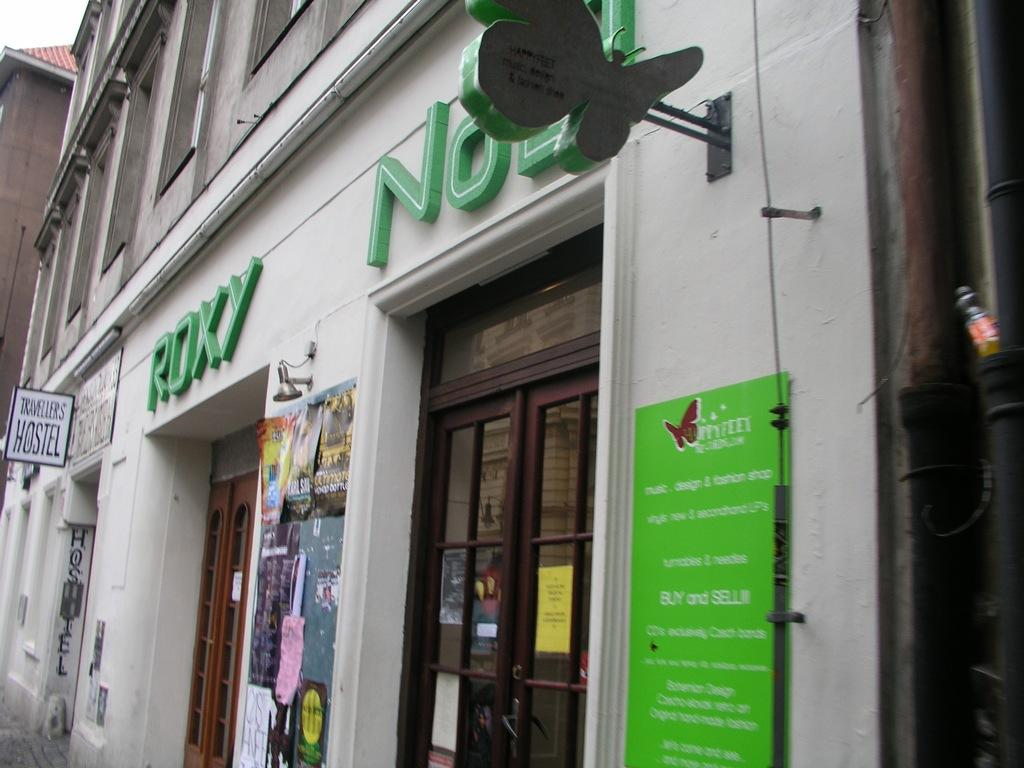What type of structures can be seen in the image? There are buildings in the image. What else is present in the image besides the buildings? There are boards with text in the image. Can you tell me where the sister is standing in the image? There is no mention of a sister in the image, so it is not possible to determine her location. What type of machine is visible in the image? There is no machine present in the image; it features buildings and boards with text. What kind of pet can be seen in the image? There is no pet present in the image. 